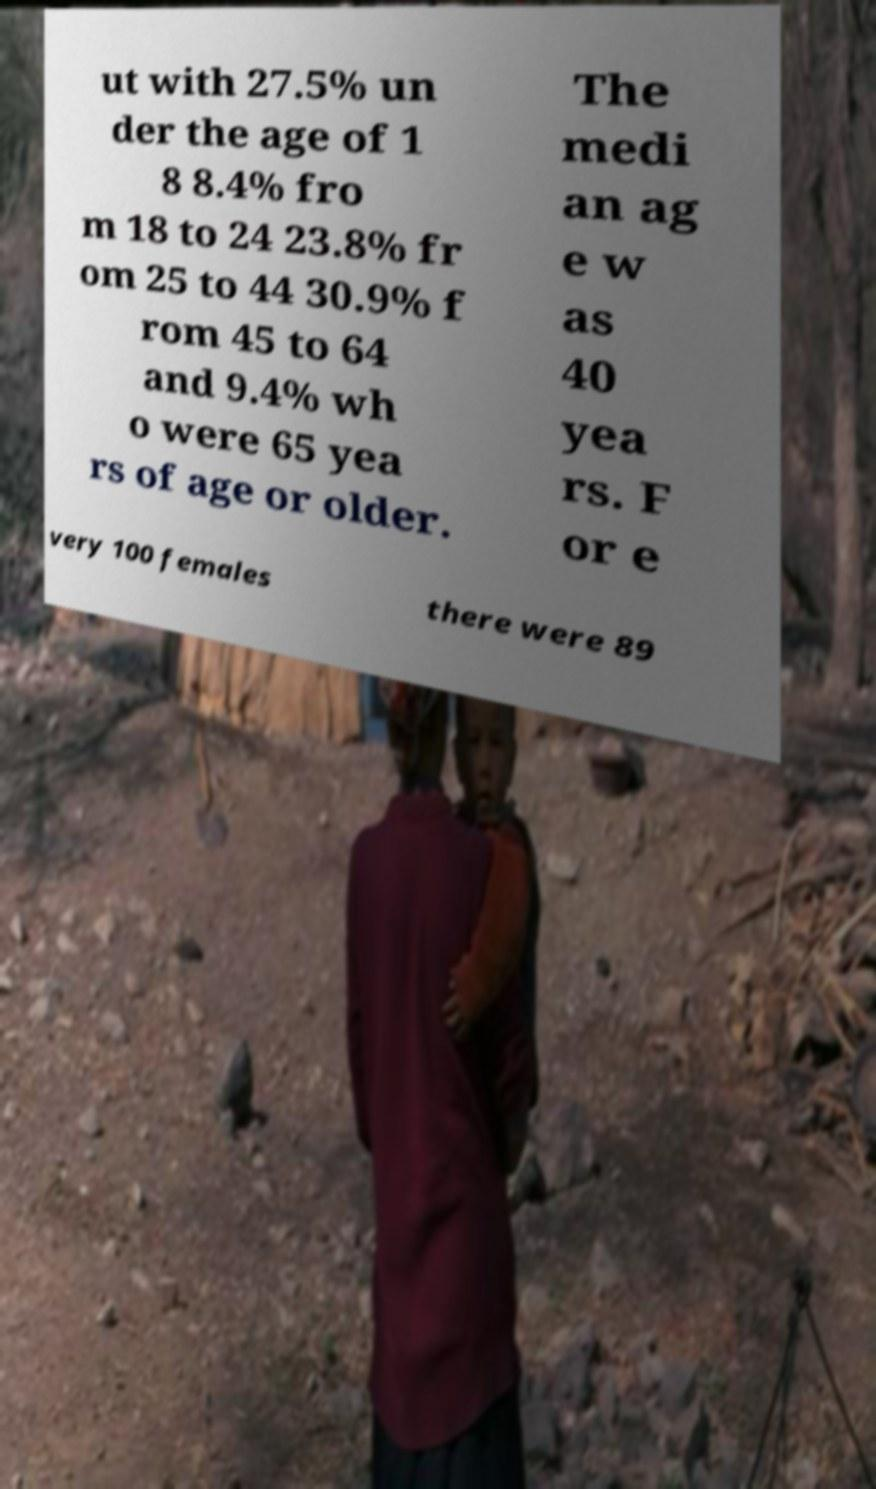What messages or text are displayed in this image? I need them in a readable, typed format. ut with 27.5% un der the age of 1 8 8.4% fro m 18 to 24 23.8% fr om 25 to 44 30.9% f rom 45 to 64 and 9.4% wh o were 65 yea rs of age or older. The medi an ag e w as 40 yea rs. F or e very 100 females there were 89 